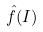<formula> <loc_0><loc_0><loc_500><loc_500>\hat { f } ( I )</formula> 